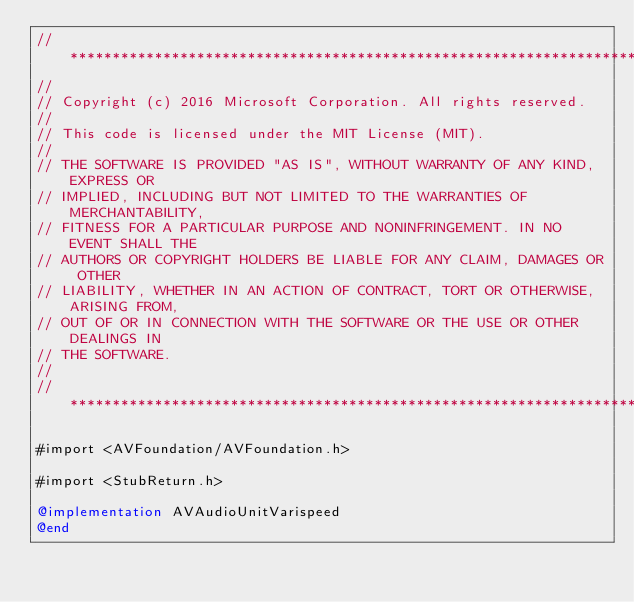Convert code to text. <code><loc_0><loc_0><loc_500><loc_500><_ObjectiveC_>//******************************************************************************
//
// Copyright (c) 2016 Microsoft Corporation. All rights reserved.
//
// This code is licensed under the MIT License (MIT).
//
// THE SOFTWARE IS PROVIDED "AS IS", WITHOUT WARRANTY OF ANY KIND, EXPRESS OR
// IMPLIED, INCLUDING BUT NOT LIMITED TO THE WARRANTIES OF MERCHANTABILITY,
// FITNESS FOR A PARTICULAR PURPOSE AND NONINFRINGEMENT. IN NO EVENT SHALL THE
// AUTHORS OR COPYRIGHT HOLDERS BE LIABLE FOR ANY CLAIM, DAMAGES OR OTHER
// LIABILITY, WHETHER IN AN ACTION OF CONTRACT, TORT OR OTHERWISE, ARISING FROM,
// OUT OF OR IN CONNECTION WITH THE SOFTWARE OR THE USE OR OTHER DEALINGS IN
// THE SOFTWARE.
//
//******************************************************************************

#import <AVFoundation/AVFoundation.h>

#import <StubReturn.h>

@implementation AVAudioUnitVarispeed
@end
</code> 